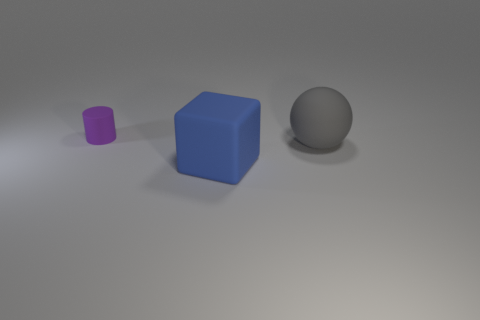What number of other objects are the same material as the ball?
Your response must be concise. 2. Is the material of the large sphere the same as the object on the left side of the big blue rubber block?
Keep it short and to the point. Yes. What number of objects are big rubber objects that are behind the blue object or large objects that are in front of the gray sphere?
Keep it short and to the point. 2. Are there more blue rubber cubes behind the large matte block than big blue matte cubes that are right of the big gray ball?
Provide a short and direct response. No. Is there any other thing that has the same size as the purple cylinder?
Keep it short and to the point. No. How many spheres are blue matte things or yellow rubber things?
Provide a succinct answer. 0. How many things are either matte things on the right side of the rubber block or cylinders?
Offer a terse response. 2. There is a thing to the left of the big matte object that is to the left of the gray rubber thing that is right of the big block; what shape is it?
Ensure brevity in your answer.  Cylinder. Is the material of the big sphere the same as the blue block?
Offer a terse response. Yes. How many big matte things are in front of the large matte object that is behind the large thing that is on the left side of the big gray ball?
Ensure brevity in your answer.  1. 